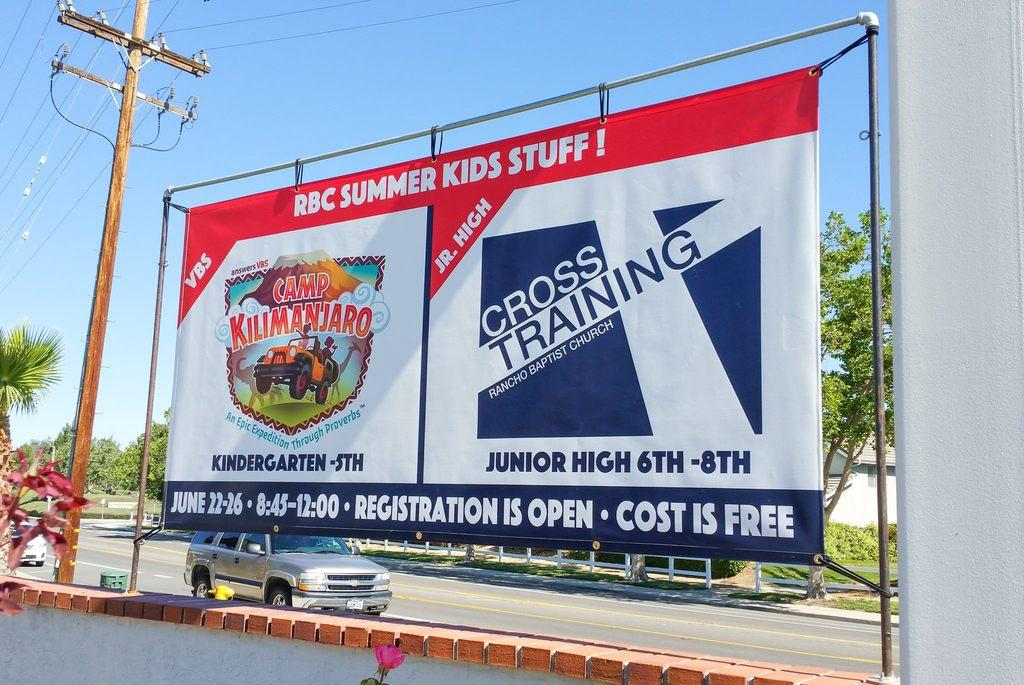<image>
Present a compact description of the photo's key features. The poster near the powerlines displays summer activities for children in the local community. 